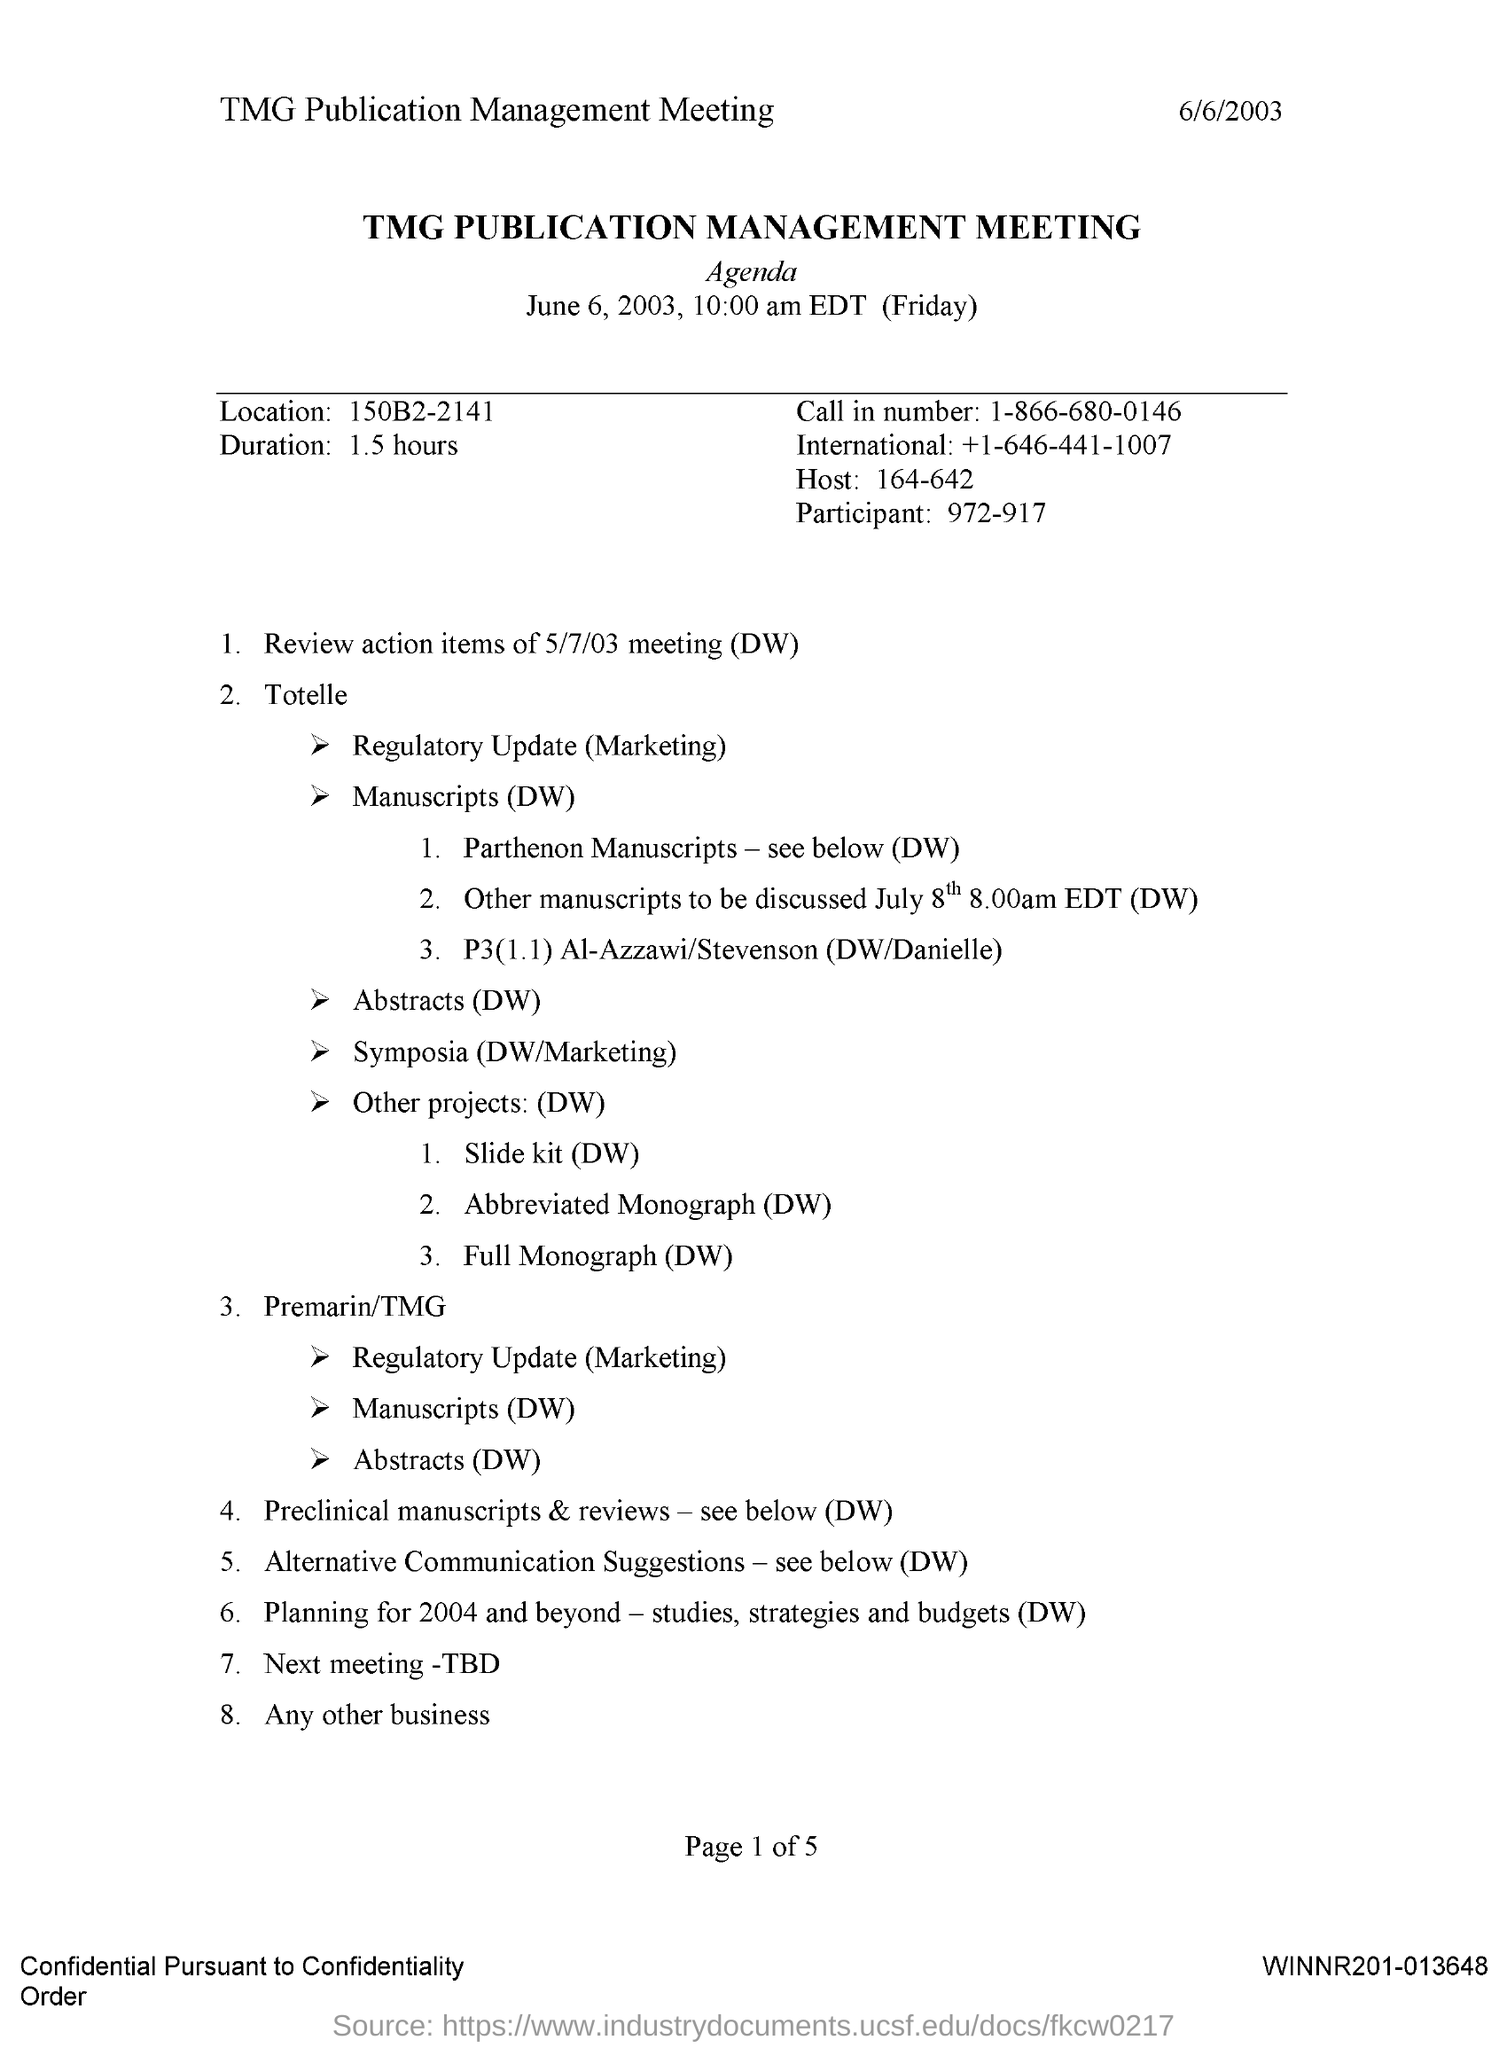Identify some key points in this picture. The duration is 1.5 hours. The TMG Publication Management Meeting is held at 10:00 am. The TMG Publication Management Meeting was held on June 6, 2003. The location is 150B2-2141. The phone number is "1-866-680-0146. 